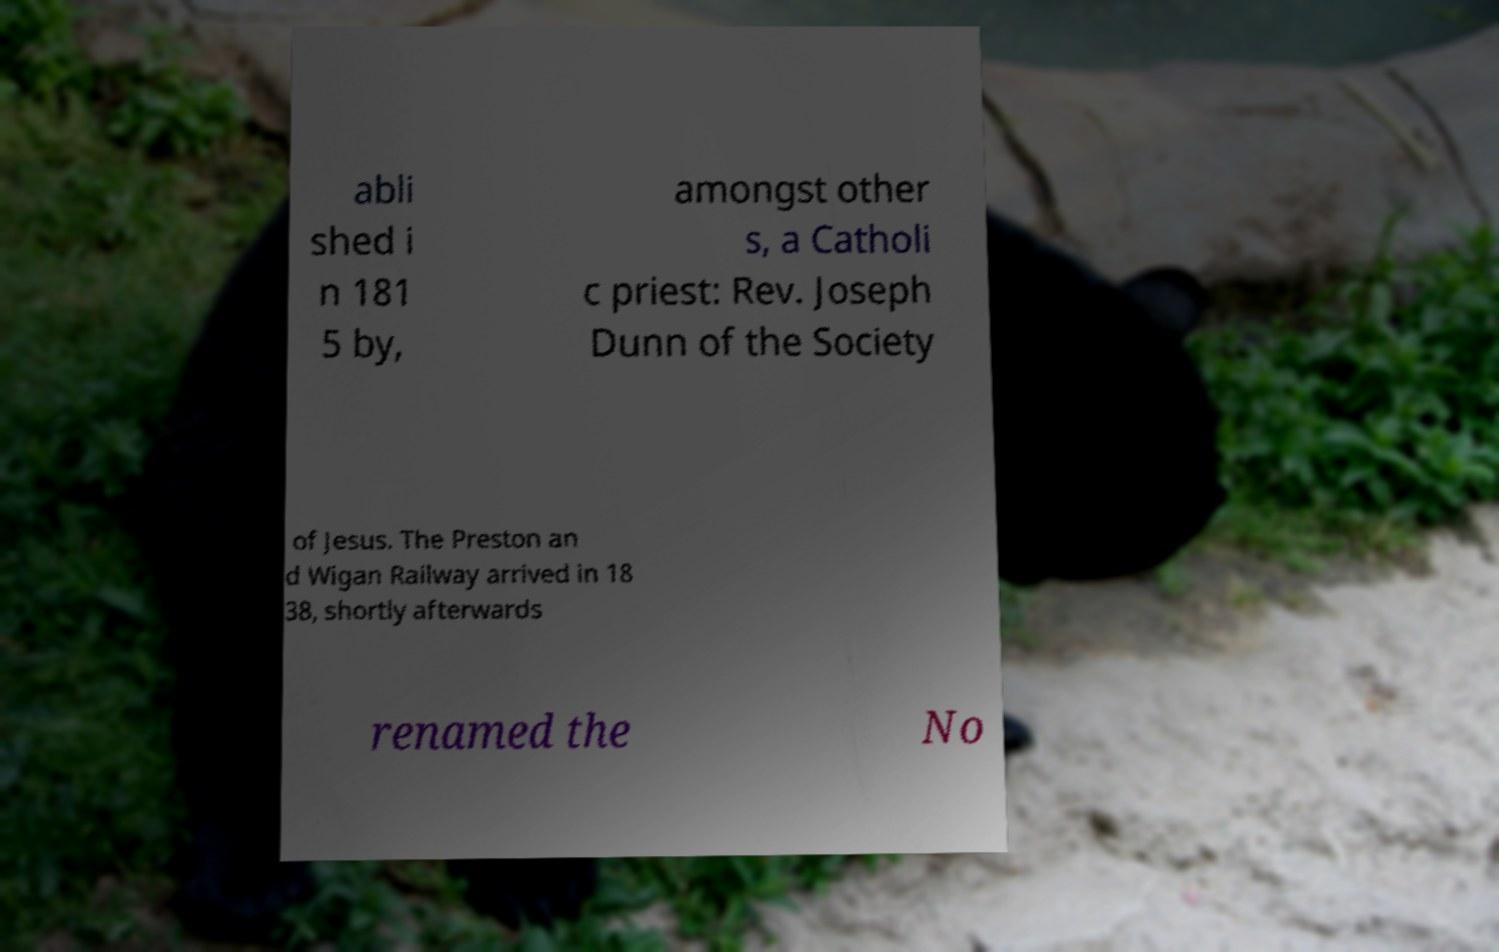Please read and relay the text visible in this image. What does it say? abli shed i n 181 5 by, amongst other s, a Catholi c priest: Rev. Joseph Dunn of the Society of Jesus. The Preston an d Wigan Railway arrived in 18 38, shortly afterwards renamed the No 